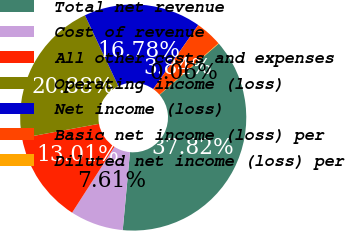Convert chart to OTSL. <chart><loc_0><loc_0><loc_500><loc_500><pie_chart><fcel>Total net revenue<fcel>Cost of revenue<fcel>All other costs and expenses<fcel>Operating income (loss)<fcel>Net income (loss)<fcel>Basic net income (loss) per<fcel>Diluted net income (loss) per<nl><fcel>37.82%<fcel>7.61%<fcel>13.01%<fcel>20.88%<fcel>16.78%<fcel>3.84%<fcel>0.06%<nl></chart> 